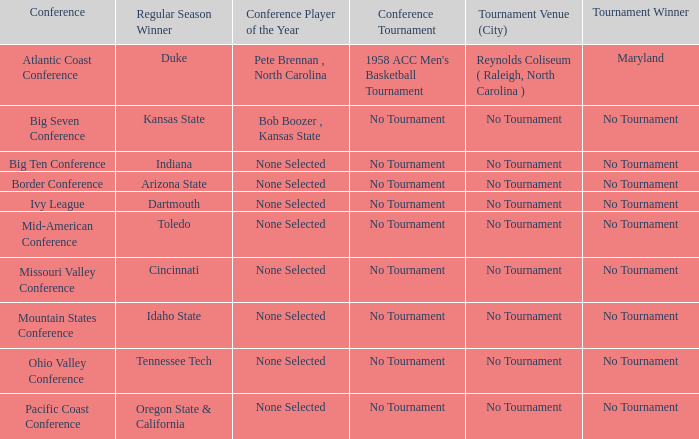Who claimed the championship title in the atlantic coast conference tournament? Maryland. 